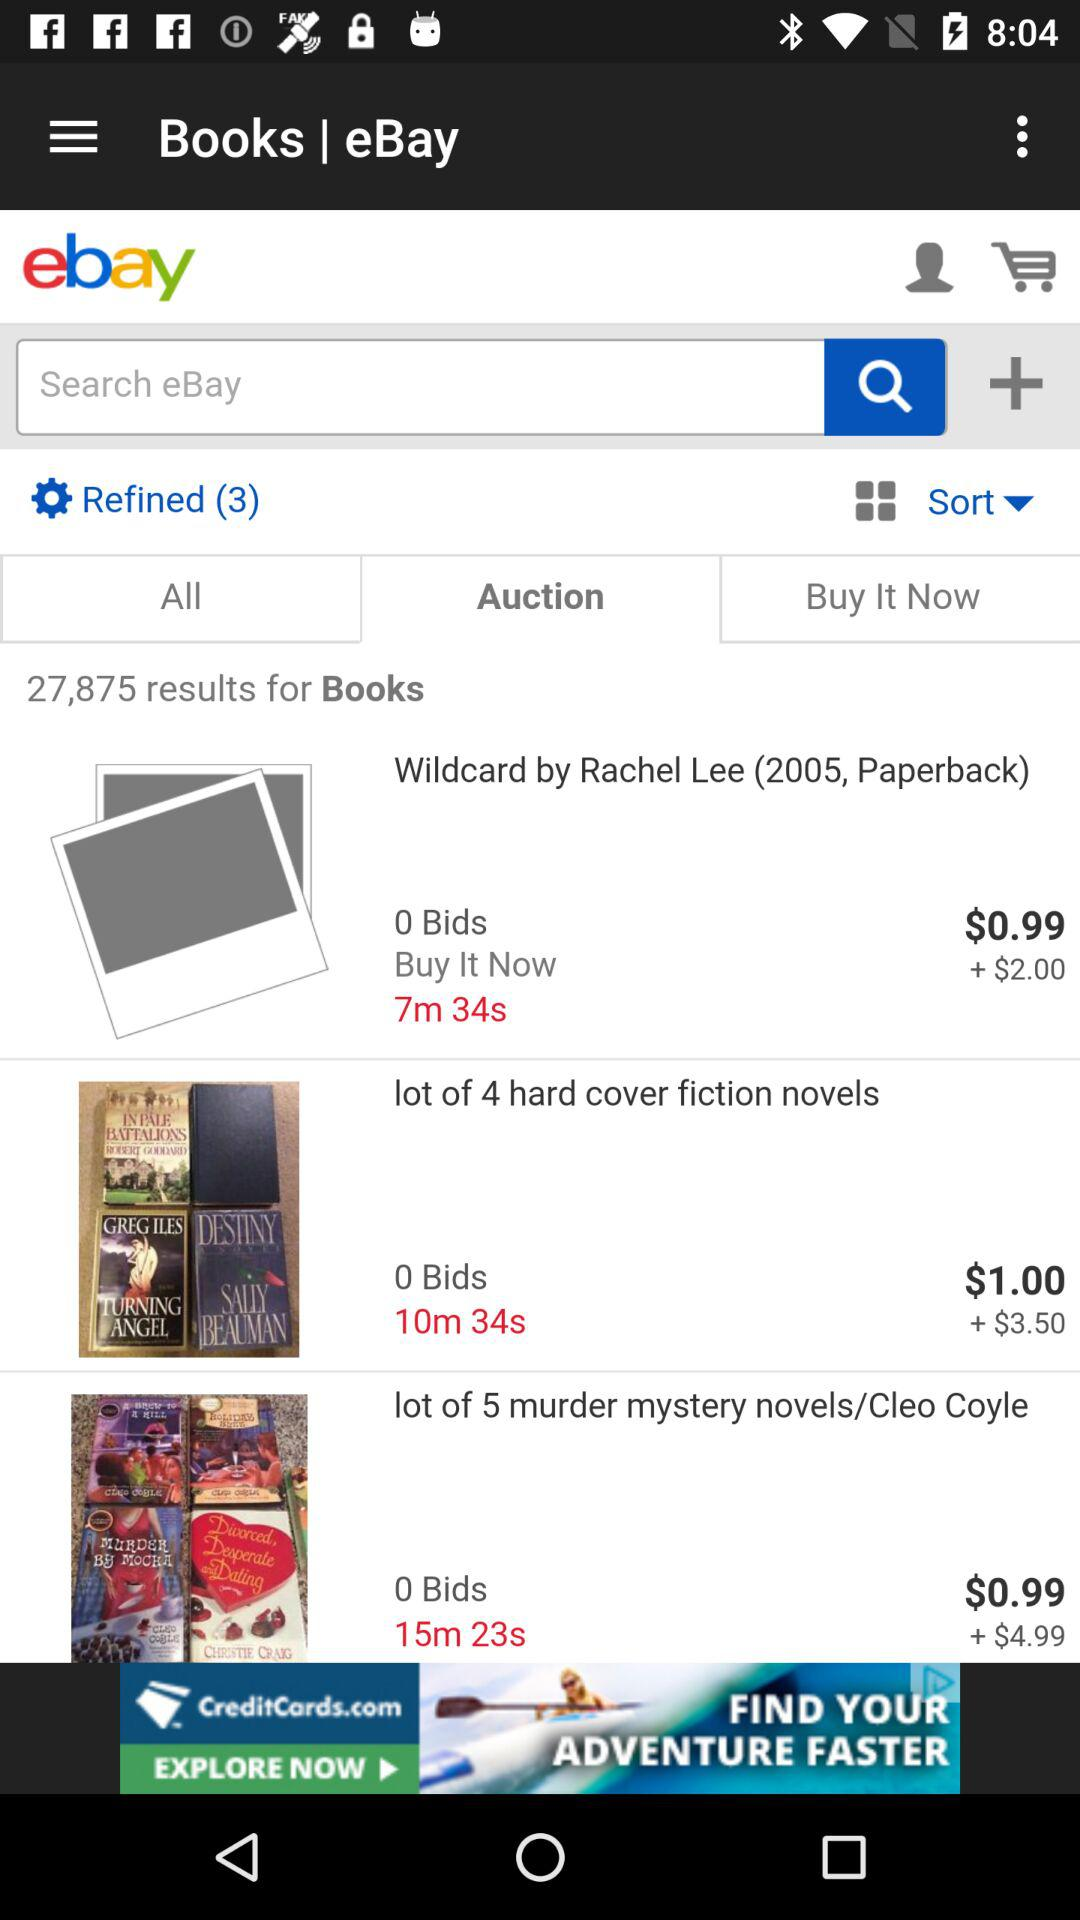What's the number of bids for "lot of 4 hard cover fiction novels"? The number of bids for "lot of 4 hard cover fiction novels" is 0. 